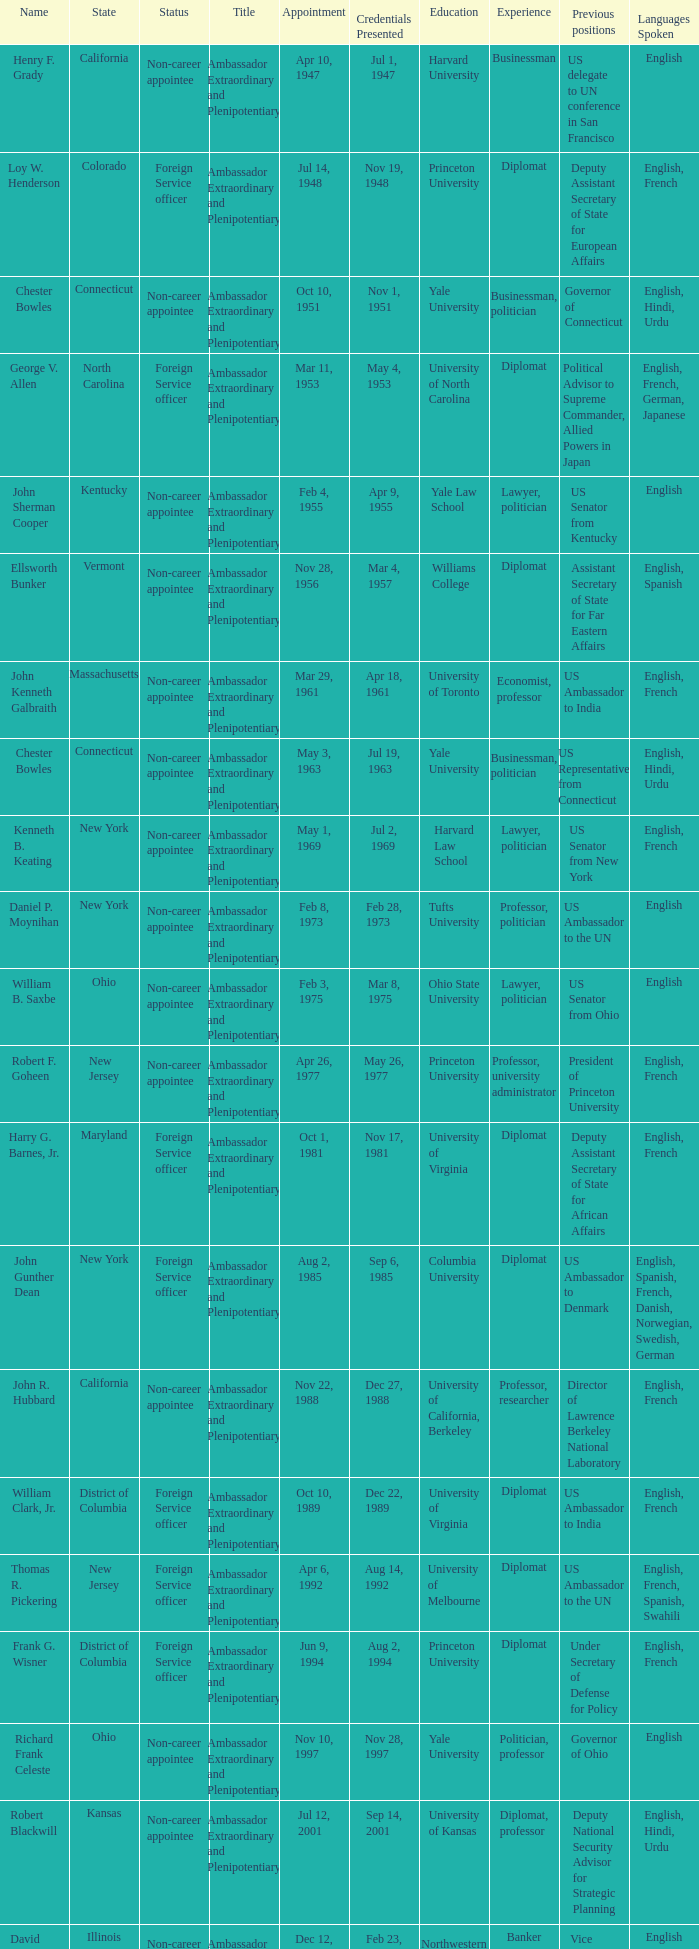What state has an appointment for jul 12, 2001? Kansas. 